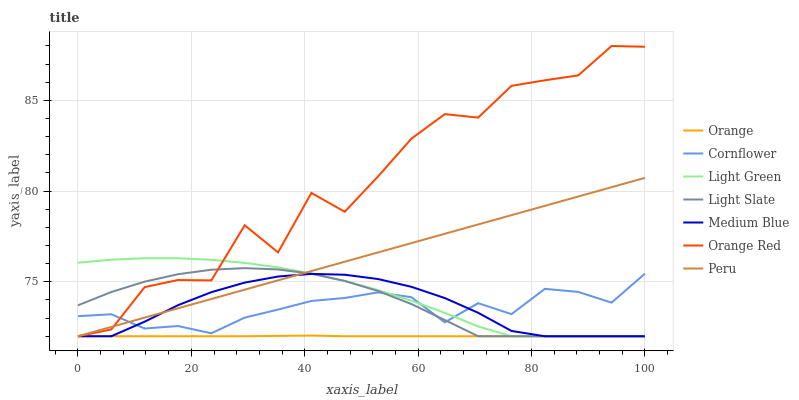Does Orange have the minimum area under the curve?
Answer yes or no. Yes. Does Orange Red have the maximum area under the curve?
Answer yes or no. Yes. Does Peru have the minimum area under the curve?
Answer yes or no. No. Does Peru have the maximum area under the curve?
Answer yes or no. No. Is Peru the smoothest?
Answer yes or no. Yes. Is Orange Red the roughest?
Answer yes or no. Yes. Is Light Slate the smoothest?
Answer yes or no. No. Is Light Slate the roughest?
Answer yes or no. No. Does Peru have the lowest value?
Answer yes or no. Yes. Does Orange Red have the highest value?
Answer yes or no. Yes. Does Peru have the highest value?
Answer yes or no. No. Is Orange less than Cornflower?
Answer yes or no. Yes. Is Cornflower greater than Orange?
Answer yes or no. Yes. Does Cornflower intersect Peru?
Answer yes or no. Yes. Is Cornflower less than Peru?
Answer yes or no. No. Is Cornflower greater than Peru?
Answer yes or no. No. Does Orange intersect Cornflower?
Answer yes or no. No. 